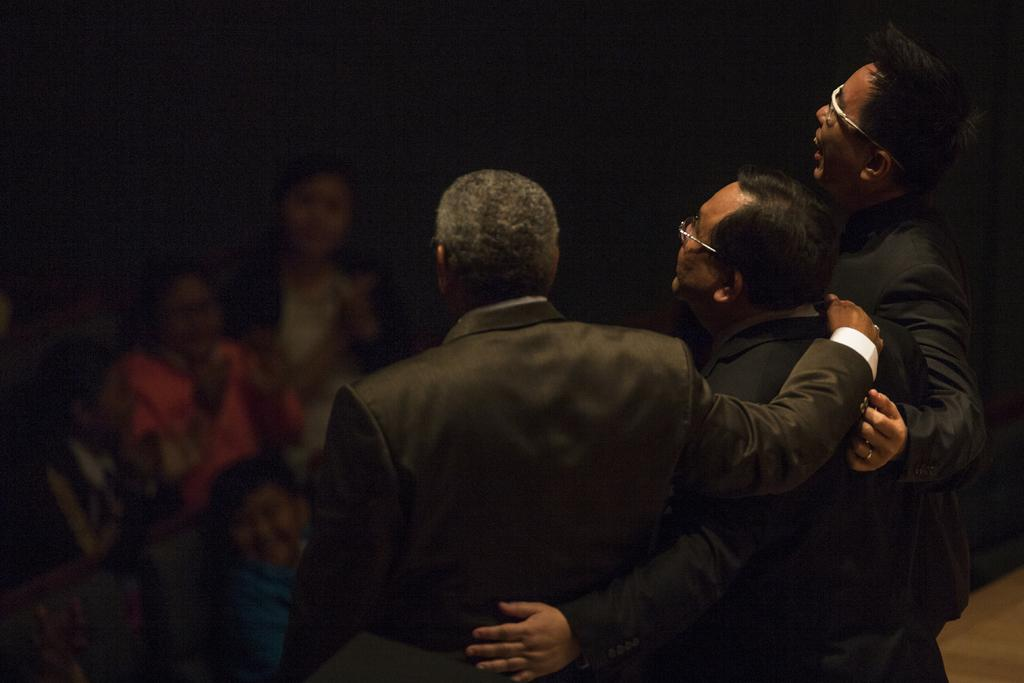How many persons are wearing black colored dresses in the image? There are three persons wearing black colored dresses in the image. What are the three persons doing in the image? The three persons are standing. Are there any other persons visible in the image? Yes, there are other persons in the image. What is the color of the background in the image? The background of the image is dark. What type of destruction can be seen in the image? There is no destruction present in the image. Can you tell me how many persons are swimming in the image? There are no persons swimming in the image. 